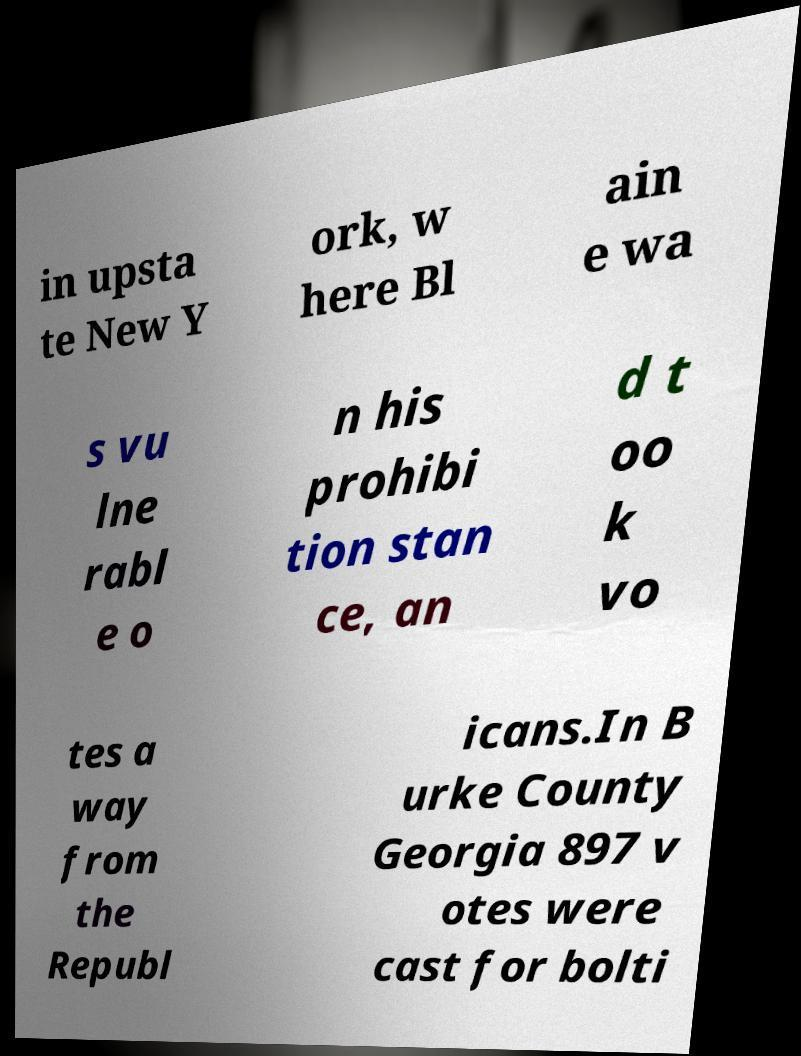Can you accurately transcribe the text from the provided image for me? in upsta te New Y ork, w here Bl ain e wa s vu lne rabl e o n his prohibi tion stan ce, an d t oo k vo tes a way from the Republ icans.In B urke County Georgia 897 v otes were cast for bolti 